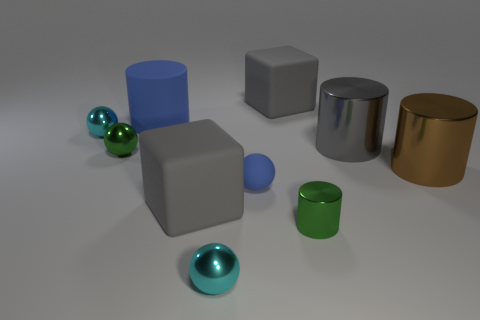Subtract all tiny green shiny spheres. How many spheres are left? 3 Subtract all brown cubes. How many cyan balls are left? 2 Subtract all blue spheres. How many spheres are left? 3 Subtract 1 balls. How many balls are left? 3 Add 6 tiny blue matte objects. How many tiny blue matte objects exist? 7 Subtract 0 red cylinders. How many objects are left? 10 Subtract all cubes. How many objects are left? 8 Subtract all cyan cylinders. Subtract all brown spheres. How many cylinders are left? 4 Subtract all small cyan objects. Subtract all small cyan spheres. How many objects are left? 6 Add 3 rubber cubes. How many rubber cubes are left? 5 